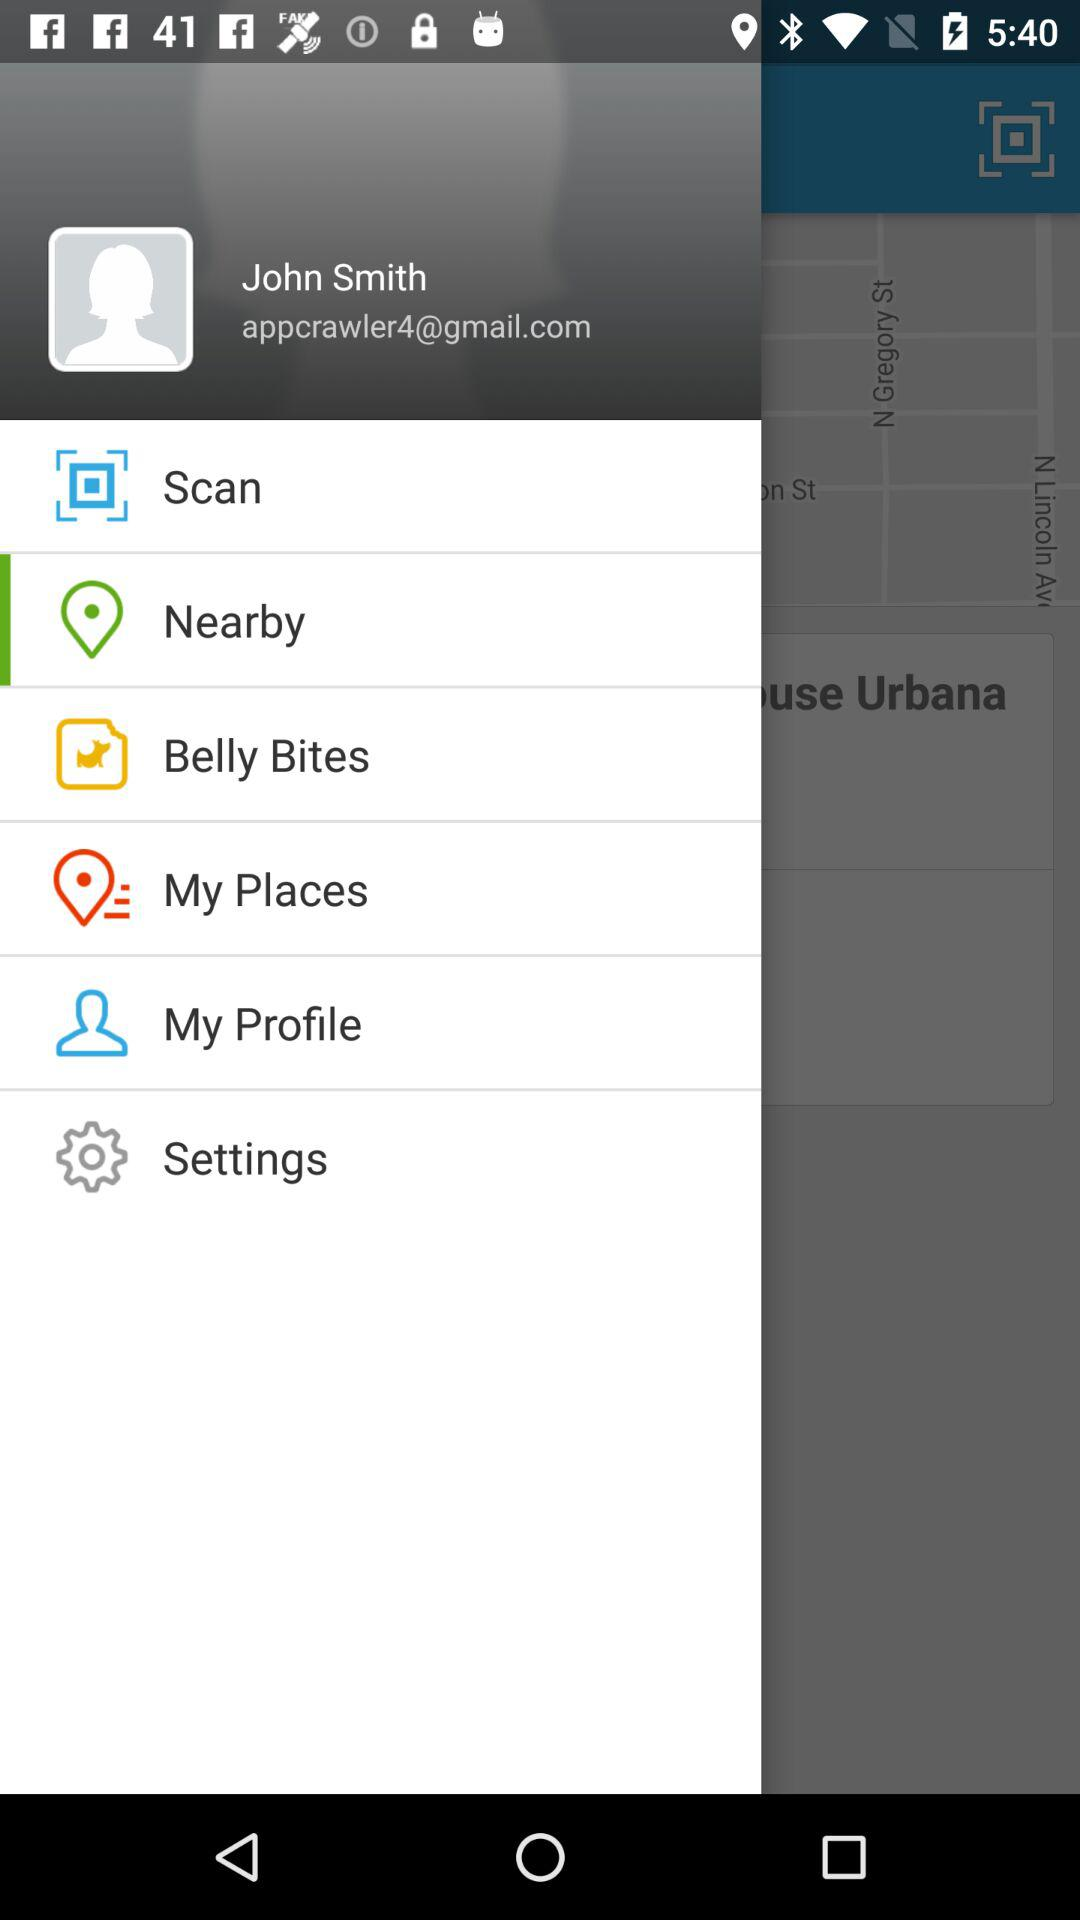What is the email address? The email address is appcrawler4@gmail.com. 